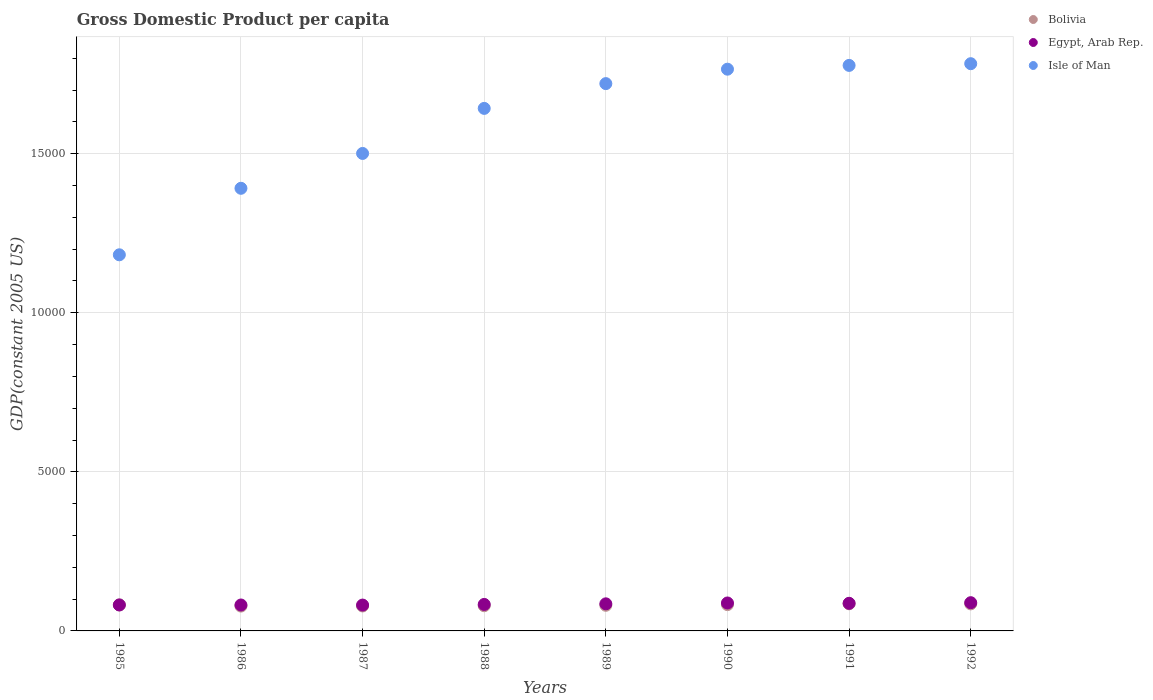Is the number of dotlines equal to the number of legend labels?
Your answer should be compact. Yes. What is the GDP per capita in Egypt, Arab Rep. in 1987?
Your answer should be compact. 812.49. Across all years, what is the maximum GDP per capita in Isle of Man?
Provide a short and direct response. 1.78e+04. Across all years, what is the minimum GDP per capita in Bolivia?
Offer a terse response. 780.57. In which year was the GDP per capita in Egypt, Arab Rep. minimum?
Offer a very short reply. 1987. What is the total GDP per capita in Bolivia in the graph?
Make the answer very short. 6507.87. What is the difference between the GDP per capita in Bolivia in 1987 and that in 1990?
Offer a very short reply. -42.18. What is the difference between the GDP per capita in Bolivia in 1992 and the GDP per capita in Egypt, Arab Rep. in 1986?
Offer a very short reply. 35.19. What is the average GDP per capita in Isle of Man per year?
Your response must be concise. 1.60e+04. In the year 1988, what is the difference between the GDP per capita in Bolivia and GDP per capita in Isle of Man?
Your answer should be compact. -1.56e+04. What is the ratio of the GDP per capita in Egypt, Arab Rep. in 1985 to that in 1987?
Provide a succinct answer. 1. Is the difference between the GDP per capita in Bolivia in 1986 and 1987 greater than the difference between the GDP per capita in Isle of Man in 1986 and 1987?
Your answer should be compact. Yes. What is the difference between the highest and the second highest GDP per capita in Bolivia?
Give a very brief answer. 2.88. What is the difference between the highest and the lowest GDP per capita in Bolivia?
Provide a succinct answer. 72.28. Is the sum of the GDP per capita in Bolivia in 1988 and 1989 greater than the maximum GDP per capita in Egypt, Arab Rep. across all years?
Make the answer very short. Yes. Is the GDP per capita in Bolivia strictly greater than the GDP per capita in Egypt, Arab Rep. over the years?
Offer a very short reply. No. How many dotlines are there?
Keep it short and to the point. 3. What is the difference between two consecutive major ticks on the Y-axis?
Offer a very short reply. 5000. Are the values on the major ticks of Y-axis written in scientific E-notation?
Provide a short and direct response. No. Where does the legend appear in the graph?
Provide a short and direct response. Top right. How many legend labels are there?
Your answer should be very brief. 3. What is the title of the graph?
Your answer should be compact. Gross Domestic Product per capita. Does "Faeroe Islands" appear as one of the legend labels in the graph?
Provide a succinct answer. No. What is the label or title of the Y-axis?
Your answer should be very brief. GDP(constant 2005 US). What is the GDP(constant 2005 US) of Bolivia in 1985?
Keep it short and to the point. 817.49. What is the GDP(constant 2005 US) in Egypt, Arab Rep. in 1985?
Give a very brief answer. 815.88. What is the GDP(constant 2005 US) in Isle of Man in 1985?
Offer a very short reply. 1.18e+04. What is the GDP(constant 2005 US) of Bolivia in 1986?
Make the answer very short. 780.57. What is the GDP(constant 2005 US) in Egypt, Arab Rep. in 1986?
Offer a very short reply. 814.79. What is the GDP(constant 2005 US) of Isle of Man in 1986?
Offer a very short reply. 1.39e+04. What is the GDP(constant 2005 US) in Bolivia in 1987?
Give a very brief answer. 784.11. What is the GDP(constant 2005 US) of Egypt, Arab Rep. in 1987?
Make the answer very short. 812.49. What is the GDP(constant 2005 US) of Isle of Man in 1987?
Provide a short and direct response. 1.50e+04. What is the GDP(constant 2005 US) of Bolivia in 1988?
Your answer should be compact. 791.25. What is the GDP(constant 2005 US) in Egypt, Arab Rep. in 1988?
Offer a terse response. 832.52. What is the GDP(constant 2005 US) of Isle of Man in 1988?
Provide a succinct answer. 1.64e+04. What is the GDP(constant 2005 US) in Bolivia in 1989?
Your answer should be very brief. 805.33. What is the GDP(constant 2005 US) in Egypt, Arab Rep. in 1989?
Provide a short and direct response. 851.4. What is the GDP(constant 2005 US) in Isle of Man in 1989?
Provide a succinct answer. 1.72e+04. What is the GDP(constant 2005 US) of Bolivia in 1990?
Keep it short and to the point. 826.29. What is the GDP(constant 2005 US) of Egypt, Arab Rep. in 1990?
Provide a short and direct response. 878.22. What is the GDP(constant 2005 US) of Isle of Man in 1990?
Give a very brief answer. 1.77e+04. What is the GDP(constant 2005 US) in Bolivia in 1991?
Provide a succinct answer. 852.86. What is the GDP(constant 2005 US) in Egypt, Arab Rep. in 1991?
Your response must be concise. 867.8. What is the GDP(constant 2005 US) in Isle of Man in 1991?
Give a very brief answer. 1.78e+04. What is the GDP(constant 2005 US) of Bolivia in 1992?
Keep it short and to the point. 849.98. What is the GDP(constant 2005 US) in Egypt, Arab Rep. in 1992?
Offer a very short reply. 887.31. What is the GDP(constant 2005 US) in Isle of Man in 1992?
Keep it short and to the point. 1.78e+04. Across all years, what is the maximum GDP(constant 2005 US) in Bolivia?
Your answer should be very brief. 852.86. Across all years, what is the maximum GDP(constant 2005 US) of Egypt, Arab Rep.?
Provide a succinct answer. 887.31. Across all years, what is the maximum GDP(constant 2005 US) in Isle of Man?
Your answer should be very brief. 1.78e+04. Across all years, what is the minimum GDP(constant 2005 US) in Bolivia?
Your response must be concise. 780.57. Across all years, what is the minimum GDP(constant 2005 US) of Egypt, Arab Rep.?
Keep it short and to the point. 812.49. Across all years, what is the minimum GDP(constant 2005 US) of Isle of Man?
Provide a short and direct response. 1.18e+04. What is the total GDP(constant 2005 US) in Bolivia in the graph?
Keep it short and to the point. 6507.87. What is the total GDP(constant 2005 US) of Egypt, Arab Rep. in the graph?
Keep it short and to the point. 6760.4. What is the total GDP(constant 2005 US) of Isle of Man in the graph?
Ensure brevity in your answer.  1.28e+05. What is the difference between the GDP(constant 2005 US) in Bolivia in 1985 and that in 1986?
Ensure brevity in your answer.  36.92. What is the difference between the GDP(constant 2005 US) in Egypt, Arab Rep. in 1985 and that in 1986?
Keep it short and to the point. 1.09. What is the difference between the GDP(constant 2005 US) of Isle of Man in 1985 and that in 1986?
Ensure brevity in your answer.  -2090.27. What is the difference between the GDP(constant 2005 US) in Bolivia in 1985 and that in 1987?
Offer a terse response. 33.38. What is the difference between the GDP(constant 2005 US) in Egypt, Arab Rep. in 1985 and that in 1987?
Provide a succinct answer. 3.38. What is the difference between the GDP(constant 2005 US) in Isle of Man in 1985 and that in 1987?
Your answer should be very brief. -3185.36. What is the difference between the GDP(constant 2005 US) of Bolivia in 1985 and that in 1988?
Your answer should be compact. 26.24. What is the difference between the GDP(constant 2005 US) in Egypt, Arab Rep. in 1985 and that in 1988?
Ensure brevity in your answer.  -16.64. What is the difference between the GDP(constant 2005 US) of Isle of Man in 1985 and that in 1988?
Your answer should be compact. -4601.39. What is the difference between the GDP(constant 2005 US) in Bolivia in 1985 and that in 1989?
Your answer should be compact. 12.16. What is the difference between the GDP(constant 2005 US) of Egypt, Arab Rep. in 1985 and that in 1989?
Ensure brevity in your answer.  -35.52. What is the difference between the GDP(constant 2005 US) in Isle of Man in 1985 and that in 1989?
Offer a very short reply. -5380.25. What is the difference between the GDP(constant 2005 US) of Bolivia in 1985 and that in 1990?
Offer a very short reply. -8.8. What is the difference between the GDP(constant 2005 US) of Egypt, Arab Rep. in 1985 and that in 1990?
Provide a short and direct response. -62.34. What is the difference between the GDP(constant 2005 US) in Isle of Man in 1985 and that in 1990?
Your response must be concise. -5833.59. What is the difference between the GDP(constant 2005 US) in Bolivia in 1985 and that in 1991?
Give a very brief answer. -35.36. What is the difference between the GDP(constant 2005 US) of Egypt, Arab Rep. in 1985 and that in 1991?
Keep it short and to the point. -51.93. What is the difference between the GDP(constant 2005 US) of Isle of Man in 1985 and that in 1991?
Ensure brevity in your answer.  -5952.38. What is the difference between the GDP(constant 2005 US) in Bolivia in 1985 and that in 1992?
Offer a terse response. -32.49. What is the difference between the GDP(constant 2005 US) of Egypt, Arab Rep. in 1985 and that in 1992?
Offer a terse response. -71.44. What is the difference between the GDP(constant 2005 US) in Isle of Man in 1985 and that in 1992?
Provide a succinct answer. -6006.14. What is the difference between the GDP(constant 2005 US) of Bolivia in 1986 and that in 1987?
Your answer should be very brief. -3.54. What is the difference between the GDP(constant 2005 US) in Egypt, Arab Rep. in 1986 and that in 1987?
Provide a short and direct response. 2.3. What is the difference between the GDP(constant 2005 US) in Isle of Man in 1986 and that in 1987?
Offer a terse response. -1095.08. What is the difference between the GDP(constant 2005 US) in Bolivia in 1986 and that in 1988?
Your response must be concise. -10.68. What is the difference between the GDP(constant 2005 US) of Egypt, Arab Rep. in 1986 and that in 1988?
Offer a terse response. -17.73. What is the difference between the GDP(constant 2005 US) in Isle of Man in 1986 and that in 1988?
Your response must be concise. -2511.12. What is the difference between the GDP(constant 2005 US) in Bolivia in 1986 and that in 1989?
Provide a succinct answer. -24.76. What is the difference between the GDP(constant 2005 US) in Egypt, Arab Rep. in 1986 and that in 1989?
Your answer should be very brief. -36.61. What is the difference between the GDP(constant 2005 US) in Isle of Man in 1986 and that in 1989?
Ensure brevity in your answer.  -3289.98. What is the difference between the GDP(constant 2005 US) in Bolivia in 1986 and that in 1990?
Ensure brevity in your answer.  -45.72. What is the difference between the GDP(constant 2005 US) in Egypt, Arab Rep. in 1986 and that in 1990?
Offer a terse response. -63.43. What is the difference between the GDP(constant 2005 US) in Isle of Man in 1986 and that in 1990?
Offer a terse response. -3743.32. What is the difference between the GDP(constant 2005 US) in Bolivia in 1986 and that in 1991?
Offer a terse response. -72.28. What is the difference between the GDP(constant 2005 US) in Egypt, Arab Rep. in 1986 and that in 1991?
Provide a succinct answer. -53.01. What is the difference between the GDP(constant 2005 US) in Isle of Man in 1986 and that in 1991?
Offer a very short reply. -3862.11. What is the difference between the GDP(constant 2005 US) in Bolivia in 1986 and that in 1992?
Ensure brevity in your answer.  -69.41. What is the difference between the GDP(constant 2005 US) in Egypt, Arab Rep. in 1986 and that in 1992?
Provide a short and direct response. -72.52. What is the difference between the GDP(constant 2005 US) of Isle of Man in 1986 and that in 1992?
Provide a succinct answer. -3915.87. What is the difference between the GDP(constant 2005 US) of Bolivia in 1987 and that in 1988?
Provide a short and direct response. -7.14. What is the difference between the GDP(constant 2005 US) in Egypt, Arab Rep. in 1987 and that in 1988?
Provide a succinct answer. -20.03. What is the difference between the GDP(constant 2005 US) in Isle of Man in 1987 and that in 1988?
Offer a terse response. -1416.04. What is the difference between the GDP(constant 2005 US) of Bolivia in 1987 and that in 1989?
Provide a short and direct response. -21.22. What is the difference between the GDP(constant 2005 US) of Egypt, Arab Rep. in 1987 and that in 1989?
Offer a terse response. -38.9. What is the difference between the GDP(constant 2005 US) of Isle of Man in 1987 and that in 1989?
Keep it short and to the point. -2194.89. What is the difference between the GDP(constant 2005 US) of Bolivia in 1987 and that in 1990?
Provide a short and direct response. -42.18. What is the difference between the GDP(constant 2005 US) of Egypt, Arab Rep. in 1987 and that in 1990?
Provide a short and direct response. -65.73. What is the difference between the GDP(constant 2005 US) of Isle of Man in 1987 and that in 1990?
Ensure brevity in your answer.  -2648.23. What is the difference between the GDP(constant 2005 US) of Bolivia in 1987 and that in 1991?
Ensure brevity in your answer.  -68.75. What is the difference between the GDP(constant 2005 US) in Egypt, Arab Rep. in 1987 and that in 1991?
Your answer should be very brief. -55.31. What is the difference between the GDP(constant 2005 US) of Isle of Man in 1987 and that in 1991?
Offer a terse response. -2767.03. What is the difference between the GDP(constant 2005 US) of Bolivia in 1987 and that in 1992?
Your response must be concise. -65.87. What is the difference between the GDP(constant 2005 US) in Egypt, Arab Rep. in 1987 and that in 1992?
Provide a short and direct response. -74.82. What is the difference between the GDP(constant 2005 US) in Isle of Man in 1987 and that in 1992?
Your answer should be very brief. -2820.79. What is the difference between the GDP(constant 2005 US) in Bolivia in 1988 and that in 1989?
Your response must be concise. -14.08. What is the difference between the GDP(constant 2005 US) in Egypt, Arab Rep. in 1988 and that in 1989?
Make the answer very short. -18.88. What is the difference between the GDP(constant 2005 US) of Isle of Man in 1988 and that in 1989?
Your response must be concise. -778.86. What is the difference between the GDP(constant 2005 US) in Bolivia in 1988 and that in 1990?
Make the answer very short. -35.04. What is the difference between the GDP(constant 2005 US) of Egypt, Arab Rep. in 1988 and that in 1990?
Keep it short and to the point. -45.7. What is the difference between the GDP(constant 2005 US) in Isle of Man in 1988 and that in 1990?
Your answer should be very brief. -1232.2. What is the difference between the GDP(constant 2005 US) in Bolivia in 1988 and that in 1991?
Your answer should be very brief. -61.61. What is the difference between the GDP(constant 2005 US) in Egypt, Arab Rep. in 1988 and that in 1991?
Give a very brief answer. -35.28. What is the difference between the GDP(constant 2005 US) in Isle of Man in 1988 and that in 1991?
Provide a short and direct response. -1350.99. What is the difference between the GDP(constant 2005 US) of Bolivia in 1988 and that in 1992?
Give a very brief answer. -58.73. What is the difference between the GDP(constant 2005 US) of Egypt, Arab Rep. in 1988 and that in 1992?
Your answer should be very brief. -54.79. What is the difference between the GDP(constant 2005 US) in Isle of Man in 1988 and that in 1992?
Your response must be concise. -1404.75. What is the difference between the GDP(constant 2005 US) in Bolivia in 1989 and that in 1990?
Give a very brief answer. -20.96. What is the difference between the GDP(constant 2005 US) of Egypt, Arab Rep. in 1989 and that in 1990?
Keep it short and to the point. -26.82. What is the difference between the GDP(constant 2005 US) of Isle of Man in 1989 and that in 1990?
Provide a short and direct response. -453.34. What is the difference between the GDP(constant 2005 US) in Bolivia in 1989 and that in 1991?
Offer a terse response. -47.53. What is the difference between the GDP(constant 2005 US) of Egypt, Arab Rep. in 1989 and that in 1991?
Give a very brief answer. -16.41. What is the difference between the GDP(constant 2005 US) of Isle of Man in 1989 and that in 1991?
Your answer should be very brief. -572.14. What is the difference between the GDP(constant 2005 US) in Bolivia in 1989 and that in 1992?
Provide a short and direct response. -44.65. What is the difference between the GDP(constant 2005 US) of Egypt, Arab Rep. in 1989 and that in 1992?
Provide a succinct answer. -35.92. What is the difference between the GDP(constant 2005 US) in Isle of Man in 1989 and that in 1992?
Offer a terse response. -625.9. What is the difference between the GDP(constant 2005 US) of Bolivia in 1990 and that in 1991?
Offer a terse response. -26.57. What is the difference between the GDP(constant 2005 US) of Egypt, Arab Rep. in 1990 and that in 1991?
Offer a terse response. 10.41. What is the difference between the GDP(constant 2005 US) of Isle of Man in 1990 and that in 1991?
Provide a short and direct response. -118.79. What is the difference between the GDP(constant 2005 US) in Bolivia in 1990 and that in 1992?
Offer a very short reply. -23.69. What is the difference between the GDP(constant 2005 US) in Egypt, Arab Rep. in 1990 and that in 1992?
Provide a short and direct response. -9.09. What is the difference between the GDP(constant 2005 US) of Isle of Man in 1990 and that in 1992?
Your answer should be compact. -172.55. What is the difference between the GDP(constant 2005 US) of Bolivia in 1991 and that in 1992?
Offer a very short reply. 2.88. What is the difference between the GDP(constant 2005 US) of Egypt, Arab Rep. in 1991 and that in 1992?
Ensure brevity in your answer.  -19.51. What is the difference between the GDP(constant 2005 US) of Isle of Man in 1991 and that in 1992?
Give a very brief answer. -53.76. What is the difference between the GDP(constant 2005 US) of Bolivia in 1985 and the GDP(constant 2005 US) of Egypt, Arab Rep. in 1986?
Provide a succinct answer. 2.7. What is the difference between the GDP(constant 2005 US) of Bolivia in 1985 and the GDP(constant 2005 US) of Isle of Man in 1986?
Your answer should be very brief. -1.31e+04. What is the difference between the GDP(constant 2005 US) of Egypt, Arab Rep. in 1985 and the GDP(constant 2005 US) of Isle of Man in 1986?
Provide a short and direct response. -1.31e+04. What is the difference between the GDP(constant 2005 US) of Bolivia in 1985 and the GDP(constant 2005 US) of Egypt, Arab Rep. in 1987?
Offer a terse response. 5. What is the difference between the GDP(constant 2005 US) in Bolivia in 1985 and the GDP(constant 2005 US) in Isle of Man in 1987?
Your response must be concise. -1.42e+04. What is the difference between the GDP(constant 2005 US) of Egypt, Arab Rep. in 1985 and the GDP(constant 2005 US) of Isle of Man in 1987?
Your response must be concise. -1.42e+04. What is the difference between the GDP(constant 2005 US) in Bolivia in 1985 and the GDP(constant 2005 US) in Egypt, Arab Rep. in 1988?
Offer a very short reply. -15.03. What is the difference between the GDP(constant 2005 US) of Bolivia in 1985 and the GDP(constant 2005 US) of Isle of Man in 1988?
Provide a succinct answer. -1.56e+04. What is the difference between the GDP(constant 2005 US) in Egypt, Arab Rep. in 1985 and the GDP(constant 2005 US) in Isle of Man in 1988?
Provide a short and direct response. -1.56e+04. What is the difference between the GDP(constant 2005 US) of Bolivia in 1985 and the GDP(constant 2005 US) of Egypt, Arab Rep. in 1989?
Offer a very short reply. -33.9. What is the difference between the GDP(constant 2005 US) of Bolivia in 1985 and the GDP(constant 2005 US) of Isle of Man in 1989?
Give a very brief answer. -1.64e+04. What is the difference between the GDP(constant 2005 US) in Egypt, Arab Rep. in 1985 and the GDP(constant 2005 US) in Isle of Man in 1989?
Provide a short and direct response. -1.64e+04. What is the difference between the GDP(constant 2005 US) of Bolivia in 1985 and the GDP(constant 2005 US) of Egypt, Arab Rep. in 1990?
Your answer should be very brief. -60.73. What is the difference between the GDP(constant 2005 US) of Bolivia in 1985 and the GDP(constant 2005 US) of Isle of Man in 1990?
Make the answer very short. -1.68e+04. What is the difference between the GDP(constant 2005 US) of Egypt, Arab Rep. in 1985 and the GDP(constant 2005 US) of Isle of Man in 1990?
Keep it short and to the point. -1.68e+04. What is the difference between the GDP(constant 2005 US) in Bolivia in 1985 and the GDP(constant 2005 US) in Egypt, Arab Rep. in 1991?
Give a very brief answer. -50.31. What is the difference between the GDP(constant 2005 US) of Bolivia in 1985 and the GDP(constant 2005 US) of Isle of Man in 1991?
Ensure brevity in your answer.  -1.70e+04. What is the difference between the GDP(constant 2005 US) of Egypt, Arab Rep. in 1985 and the GDP(constant 2005 US) of Isle of Man in 1991?
Offer a terse response. -1.70e+04. What is the difference between the GDP(constant 2005 US) of Bolivia in 1985 and the GDP(constant 2005 US) of Egypt, Arab Rep. in 1992?
Give a very brief answer. -69.82. What is the difference between the GDP(constant 2005 US) in Bolivia in 1985 and the GDP(constant 2005 US) in Isle of Man in 1992?
Your answer should be very brief. -1.70e+04. What is the difference between the GDP(constant 2005 US) of Egypt, Arab Rep. in 1985 and the GDP(constant 2005 US) of Isle of Man in 1992?
Make the answer very short. -1.70e+04. What is the difference between the GDP(constant 2005 US) of Bolivia in 1986 and the GDP(constant 2005 US) of Egypt, Arab Rep. in 1987?
Offer a terse response. -31.92. What is the difference between the GDP(constant 2005 US) in Bolivia in 1986 and the GDP(constant 2005 US) in Isle of Man in 1987?
Offer a terse response. -1.42e+04. What is the difference between the GDP(constant 2005 US) in Egypt, Arab Rep. in 1986 and the GDP(constant 2005 US) in Isle of Man in 1987?
Your answer should be very brief. -1.42e+04. What is the difference between the GDP(constant 2005 US) in Bolivia in 1986 and the GDP(constant 2005 US) in Egypt, Arab Rep. in 1988?
Your answer should be compact. -51.95. What is the difference between the GDP(constant 2005 US) of Bolivia in 1986 and the GDP(constant 2005 US) of Isle of Man in 1988?
Your answer should be very brief. -1.56e+04. What is the difference between the GDP(constant 2005 US) of Egypt, Arab Rep. in 1986 and the GDP(constant 2005 US) of Isle of Man in 1988?
Offer a terse response. -1.56e+04. What is the difference between the GDP(constant 2005 US) of Bolivia in 1986 and the GDP(constant 2005 US) of Egypt, Arab Rep. in 1989?
Provide a short and direct response. -70.82. What is the difference between the GDP(constant 2005 US) in Bolivia in 1986 and the GDP(constant 2005 US) in Isle of Man in 1989?
Make the answer very short. -1.64e+04. What is the difference between the GDP(constant 2005 US) of Egypt, Arab Rep. in 1986 and the GDP(constant 2005 US) of Isle of Man in 1989?
Offer a very short reply. -1.64e+04. What is the difference between the GDP(constant 2005 US) of Bolivia in 1986 and the GDP(constant 2005 US) of Egypt, Arab Rep. in 1990?
Your answer should be compact. -97.64. What is the difference between the GDP(constant 2005 US) in Bolivia in 1986 and the GDP(constant 2005 US) in Isle of Man in 1990?
Offer a very short reply. -1.69e+04. What is the difference between the GDP(constant 2005 US) in Egypt, Arab Rep. in 1986 and the GDP(constant 2005 US) in Isle of Man in 1990?
Offer a terse response. -1.68e+04. What is the difference between the GDP(constant 2005 US) in Bolivia in 1986 and the GDP(constant 2005 US) in Egypt, Arab Rep. in 1991?
Offer a terse response. -87.23. What is the difference between the GDP(constant 2005 US) of Bolivia in 1986 and the GDP(constant 2005 US) of Isle of Man in 1991?
Offer a very short reply. -1.70e+04. What is the difference between the GDP(constant 2005 US) of Egypt, Arab Rep. in 1986 and the GDP(constant 2005 US) of Isle of Man in 1991?
Ensure brevity in your answer.  -1.70e+04. What is the difference between the GDP(constant 2005 US) in Bolivia in 1986 and the GDP(constant 2005 US) in Egypt, Arab Rep. in 1992?
Make the answer very short. -106.74. What is the difference between the GDP(constant 2005 US) of Bolivia in 1986 and the GDP(constant 2005 US) of Isle of Man in 1992?
Keep it short and to the point. -1.70e+04. What is the difference between the GDP(constant 2005 US) in Egypt, Arab Rep. in 1986 and the GDP(constant 2005 US) in Isle of Man in 1992?
Provide a succinct answer. -1.70e+04. What is the difference between the GDP(constant 2005 US) of Bolivia in 1987 and the GDP(constant 2005 US) of Egypt, Arab Rep. in 1988?
Offer a terse response. -48.41. What is the difference between the GDP(constant 2005 US) in Bolivia in 1987 and the GDP(constant 2005 US) in Isle of Man in 1988?
Offer a terse response. -1.56e+04. What is the difference between the GDP(constant 2005 US) in Egypt, Arab Rep. in 1987 and the GDP(constant 2005 US) in Isle of Man in 1988?
Your response must be concise. -1.56e+04. What is the difference between the GDP(constant 2005 US) of Bolivia in 1987 and the GDP(constant 2005 US) of Egypt, Arab Rep. in 1989?
Give a very brief answer. -67.29. What is the difference between the GDP(constant 2005 US) of Bolivia in 1987 and the GDP(constant 2005 US) of Isle of Man in 1989?
Make the answer very short. -1.64e+04. What is the difference between the GDP(constant 2005 US) of Egypt, Arab Rep. in 1987 and the GDP(constant 2005 US) of Isle of Man in 1989?
Your answer should be very brief. -1.64e+04. What is the difference between the GDP(constant 2005 US) in Bolivia in 1987 and the GDP(constant 2005 US) in Egypt, Arab Rep. in 1990?
Your answer should be very brief. -94.11. What is the difference between the GDP(constant 2005 US) of Bolivia in 1987 and the GDP(constant 2005 US) of Isle of Man in 1990?
Offer a terse response. -1.69e+04. What is the difference between the GDP(constant 2005 US) in Egypt, Arab Rep. in 1987 and the GDP(constant 2005 US) in Isle of Man in 1990?
Make the answer very short. -1.68e+04. What is the difference between the GDP(constant 2005 US) of Bolivia in 1987 and the GDP(constant 2005 US) of Egypt, Arab Rep. in 1991?
Ensure brevity in your answer.  -83.69. What is the difference between the GDP(constant 2005 US) in Bolivia in 1987 and the GDP(constant 2005 US) in Isle of Man in 1991?
Provide a succinct answer. -1.70e+04. What is the difference between the GDP(constant 2005 US) in Egypt, Arab Rep. in 1987 and the GDP(constant 2005 US) in Isle of Man in 1991?
Give a very brief answer. -1.70e+04. What is the difference between the GDP(constant 2005 US) in Bolivia in 1987 and the GDP(constant 2005 US) in Egypt, Arab Rep. in 1992?
Offer a terse response. -103.2. What is the difference between the GDP(constant 2005 US) in Bolivia in 1987 and the GDP(constant 2005 US) in Isle of Man in 1992?
Keep it short and to the point. -1.70e+04. What is the difference between the GDP(constant 2005 US) in Egypt, Arab Rep. in 1987 and the GDP(constant 2005 US) in Isle of Man in 1992?
Offer a terse response. -1.70e+04. What is the difference between the GDP(constant 2005 US) in Bolivia in 1988 and the GDP(constant 2005 US) in Egypt, Arab Rep. in 1989?
Your answer should be compact. -60.15. What is the difference between the GDP(constant 2005 US) in Bolivia in 1988 and the GDP(constant 2005 US) in Isle of Man in 1989?
Your answer should be very brief. -1.64e+04. What is the difference between the GDP(constant 2005 US) of Egypt, Arab Rep. in 1988 and the GDP(constant 2005 US) of Isle of Man in 1989?
Offer a terse response. -1.64e+04. What is the difference between the GDP(constant 2005 US) in Bolivia in 1988 and the GDP(constant 2005 US) in Egypt, Arab Rep. in 1990?
Offer a terse response. -86.97. What is the difference between the GDP(constant 2005 US) in Bolivia in 1988 and the GDP(constant 2005 US) in Isle of Man in 1990?
Ensure brevity in your answer.  -1.69e+04. What is the difference between the GDP(constant 2005 US) in Egypt, Arab Rep. in 1988 and the GDP(constant 2005 US) in Isle of Man in 1990?
Your response must be concise. -1.68e+04. What is the difference between the GDP(constant 2005 US) of Bolivia in 1988 and the GDP(constant 2005 US) of Egypt, Arab Rep. in 1991?
Make the answer very short. -76.55. What is the difference between the GDP(constant 2005 US) in Bolivia in 1988 and the GDP(constant 2005 US) in Isle of Man in 1991?
Give a very brief answer. -1.70e+04. What is the difference between the GDP(constant 2005 US) in Egypt, Arab Rep. in 1988 and the GDP(constant 2005 US) in Isle of Man in 1991?
Your answer should be compact. -1.69e+04. What is the difference between the GDP(constant 2005 US) of Bolivia in 1988 and the GDP(constant 2005 US) of Egypt, Arab Rep. in 1992?
Keep it short and to the point. -96.06. What is the difference between the GDP(constant 2005 US) in Bolivia in 1988 and the GDP(constant 2005 US) in Isle of Man in 1992?
Ensure brevity in your answer.  -1.70e+04. What is the difference between the GDP(constant 2005 US) of Egypt, Arab Rep. in 1988 and the GDP(constant 2005 US) of Isle of Man in 1992?
Offer a very short reply. -1.70e+04. What is the difference between the GDP(constant 2005 US) in Bolivia in 1989 and the GDP(constant 2005 US) in Egypt, Arab Rep. in 1990?
Offer a terse response. -72.89. What is the difference between the GDP(constant 2005 US) in Bolivia in 1989 and the GDP(constant 2005 US) in Isle of Man in 1990?
Your answer should be compact. -1.68e+04. What is the difference between the GDP(constant 2005 US) in Egypt, Arab Rep. in 1989 and the GDP(constant 2005 US) in Isle of Man in 1990?
Offer a very short reply. -1.68e+04. What is the difference between the GDP(constant 2005 US) in Bolivia in 1989 and the GDP(constant 2005 US) in Egypt, Arab Rep. in 1991?
Give a very brief answer. -62.47. What is the difference between the GDP(constant 2005 US) of Bolivia in 1989 and the GDP(constant 2005 US) of Isle of Man in 1991?
Ensure brevity in your answer.  -1.70e+04. What is the difference between the GDP(constant 2005 US) of Egypt, Arab Rep. in 1989 and the GDP(constant 2005 US) of Isle of Man in 1991?
Your response must be concise. -1.69e+04. What is the difference between the GDP(constant 2005 US) of Bolivia in 1989 and the GDP(constant 2005 US) of Egypt, Arab Rep. in 1992?
Provide a succinct answer. -81.98. What is the difference between the GDP(constant 2005 US) in Bolivia in 1989 and the GDP(constant 2005 US) in Isle of Man in 1992?
Your response must be concise. -1.70e+04. What is the difference between the GDP(constant 2005 US) in Egypt, Arab Rep. in 1989 and the GDP(constant 2005 US) in Isle of Man in 1992?
Your response must be concise. -1.70e+04. What is the difference between the GDP(constant 2005 US) of Bolivia in 1990 and the GDP(constant 2005 US) of Egypt, Arab Rep. in 1991?
Your answer should be very brief. -41.51. What is the difference between the GDP(constant 2005 US) of Bolivia in 1990 and the GDP(constant 2005 US) of Isle of Man in 1991?
Provide a short and direct response. -1.69e+04. What is the difference between the GDP(constant 2005 US) of Egypt, Arab Rep. in 1990 and the GDP(constant 2005 US) of Isle of Man in 1991?
Make the answer very short. -1.69e+04. What is the difference between the GDP(constant 2005 US) in Bolivia in 1990 and the GDP(constant 2005 US) in Egypt, Arab Rep. in 1992?
Offer a very short reply. -61.02. What is the difference between the GDP(constant 2005 US) of Bolivia in 1990 and the GDP(constant 2005 US) of Isle of Man in 1992?
Your answer should be compact. -1.70e+04. What is the difference between the GDP(constant 2005 US) in Egypt, Arab Rep. in 1990 and the GDP(constant 2005 US) in Isle of Man in 1992?
Keep it short and to the point. -1.69e+04. What is the difference between the GDP(constant 2005 US) in Bolivia in 1991 and the GDP(constant 2005 US) in Egypt, Arab Rep. in 1992?
Offer a terse response. -34.46. What is the difference between the GDP(constant 2005 US) in Bolivia in 1991 and the GDP(constant 2005 US) in Isle of Man in 1992?
Make the answer very short. -1.70e+04. What is the difference between the GDP(constant 2005 US) in Egypt, Arab Rep. in 1991 and the GDP(constant 2005 US) in Isle of Man in 1992?
Provide a short and direct response. -1.70e+04. What is the average GDP(constant 2005 US) in Bolivia per year?
Give a very brief answer. 813.48. What is the average GDP(constant 2005 US) of Egypt, Arab Rep. per year?
Keep it short and to the point. 845.05. What is the average GDP(constant 2005 US) in Isle of Man per year?
Provide a short and direct response. 1.60e+04. In the year 1985, what is the difference between the GDP(constant 2005 US) of Bolivia and GDP(constant 2005 US) of Egypt, Arab Rep.?
Provide a short and direct response. 1.61. In the year 1985, what is the difference between the GDP(constant 2005 US) in Bolivia and GDP(constant 2005 US) in Isle of Man?
Keep it short and to the point. -1.10e+04. In the year 1985, what is the difference between the GDP(constant 2005 US) in Egypt, Arab Rep. and GDP(constant 2005 US) in Isle of Man?
Your answer should be compact. -1.10e+04. In the year 1986, what is the difference between the GDP(constant 2005 US) in Bolivia and GDP(constant 2005 US) in Egypt, Arab Rep.?
Offer a terse response. -34.22. In the year 1986, what is the difference between the GDP(constant 2005 US) in Bolivia and GDP(constant 2005 US) in Isle of Man?
Make the answer very short. -1.31e+04. In the year 1986, what is the difference between the GDP(constant 2005 US) of Egypt, Arab Rep. and GDP(constant 2005 US) of Isle of Man?
Your answer should be compact. -1.31e+04. In the year 1987, what is the difference between the GDP(constant 2005 US) in Bolivia and GDP(constant 2005 US) in Egypt, Arab Rep.?
Ensure brevity in your answer.  -28.38. In the year 1987, what is the difference between the GDP(constant 2005 US) in Bolivia and GDP(constant 2005 US) in Isle of Man?
Make the answer very short. -1.42e+04. In the year 1987, what is the difference between the GDP(constant 2005 US) in Egypt, Arab Rep. and GDP(constant 2005 US) in Isle of Man?
Provide a succinct answer. -1.42e+04. In the year 1988, what is the difference between the GDP(constant 2005 US) in Bolivia and GDP(constant 2005 US) in Egypt, Arab Rep.?
Provide a succinct answer. -41.27. In the year 1988, what is the difference between the GDP(constant 2005 US) in Bolivia and GDP(constant 2005 US) in Isle of Man?
Offer a terse response. -1.56e+04. In the year 1988, what is the difference between the GDP(constant 2005 US) in Egypt, Arab Rep. and GDP(constant 2005 US) in Isle of Man?
Your answer should be compact. -1.56e+04. In the year 1989, what is the difference between the GDP(constant 2005 US) in Bolivia and GDP(constant 2005 US) in Egypt, Arab Rep.?
Your answer should be very brief. -46.07. In the year 1989, what is the difference between the GDP(constant 2005 US) in Bolivia and GDP(constant 2005 US) in Isle of Man?
Provide a succinct answer. -1.64e+04. In the year 1989, what is the difference between the GDP(constant 2005 US) in Egypt, Arab Rep. and GDP(constant 2005 US) in Isle of Man?
Your answer should be compact. -1.63e+04. In the year 1990, what is the difference between the GDP(constant 2005 US) in Bolivia and GDP(constant 2005 US) in Egypt, Arab Rep.?
Offer a terse response. -51.93. In the year 1990, what is the difference between the GDP(constant 2005 US) of Bolivia and GDP(constant 2005 US) of Isle of Man?
Your response must be concise. -1.68e+04. In the year 1990, what is the difference between the GDP(constant 2005 US) in Egypt, Arab Rep. and GDP(constant 2005 US) in Isle of Man?
Your response must be concise. -1.68e+04. In the year 1991, what is the difference between the GDP(constant 2005 US) in Bolivia and GDP(constant 2005 US) in Egypt, Arab Rep.?
Keep it short and to the point. -14.95. In the year 1991, what is the difference between the GDP(constant 2005 US) in Bolivia and GDP(constant 2005 US) in Isle of Man?
Your response must be concise. -1.69e+04. In the year 1991, what is the difference between the GDP(constant 2005 US) in Egypt, Arab Rep. and GDP(constant 2005 US) in Isle of Man?
Make the answer very short. -1.69e+04. In the year 1992, what is the difference between the GDP(constant 2005 US) of Bolivia and GDP(constant 2005 US) of Egypt, Arab Rep.?
Provide a short and direct response. -37.33. In the year 1992, what is the difference between the GDP(constant 2005 US) in Bolivia and GDP(constant 2005 US) in Isle of Man?
Provide a short and direct response. -1.70e+04. In the year 1992, what is the difference between the GDP(constant 2005 US) of Egypt, Arab Rep. and GDP(constant 2005 US) of Isle of Man?
Your answer should be compact. -1.69e+04. What is the ratio of the GDP(constant 2005 US) in Bolivia in 1985 to that in 1986?
Provide a short and direct response. 1.05. What is the ratio of the GDP(constant 2005 US) in Egypt, Arab Rep. in 1985 to that in 1986?
Ensure brevity in your answer.  1. What is the ratio of the GDP(constant 2005 US) in Isle of Man in 1985 to that in 1986?
Provide a short and direct response. 0.85. What is the ratio of the GDP(constant 2005 US) of Bolivia in 1985 to that in 1987?
Provide a succinct answer. 1.04. What is the ratio of the GDP(constant 2005 US) of Isle of Man in 1985 to that in 1987?
Provide a succinct answer. 0.79. What is the ratio of the GDP(constant 2005 US) in Bolivia in 1985 to that in 1988?
Your response must be concise. 1.03. What is the ratio of the GDP(constant 2005 US) in Egypt, Arab Rep. in 1985 to that in 1988?
Your answer should be very brief. 0.98. What is the ratio of the GDP(constant 2005 US) of Isle of Man in 1985 to that in 1988?
Your answer should be compact. 0.72. What is the ratio of the GDP(constant 2005 US) in Bolivia in 1985 to that in 1989?
Make the answer very short. 1.02. What is the ratio of the GDP(constant 2005 US) of Isle of Man in 1985 to that in 1989?
Your answer should be compact. 0.69. What is the ratio of the GDP(constant 2005 US) in Bolivia in 1985 to that in 1990?
Your answer should be compact. 0.99. What is the ratio of the GDP(constant 2005 US) in Egypt, Arab Rep. in 1985 to that in 1990?
Your response must be concise. 0.93. What is the ratio of the GDP(constant 2005 US) of Isle of Man in 1985 to that in 1990?
Your answer should be very brief. 0.67. What is the ratio of the GDP(constant 2005 US) of Bolivia in 1985 to that in 1991?
Your answer should be very brief. 0.96. What is the ratio of the GDP(constant 2005 US) in Egypt, Arab Rep. in 1985 to that in 1991?
Provide a short and direct response. 0.94. What is the ratio of the GDP(constant 2005 US) in Isle of Man in 1985 to that in 1991?
Give a very brief answer. 0.67. What is the ratio of the GDP(constant 2005 US) of Bolivia in 1985 to that in 1992?
Your response must be concise. 0.96. What is the ratio of the GDP(constant 2005 US) of Egypt, Arab Rep. in 1985 to that in 1992?
Provide a succinct answer. 0.92. What is the ratio of the GDP(constant 2005 US) of Isle of Man in 1985 to that in 1992?
Provide a short and direct response. 0.66. What is the ratio of the GDP(constant 2005 US) in Bolivia in 1986 to that in 1987?
Provide a succinct answer. 1. What is the ratio of the GDP(constant 2005 US) in Egypt, Arab Rep. in 1986 to that in 1987?
Your answer should be compact. 1. What is the ratio of the GDP(constant 2005 US) of Isle of Man in 1986 to that in 1987?
Offer a terse response. 0.93. What is the ratio of the GDP(constant 2005 US) of Bolivia in 1986 to that in 1988?
Your answer should be very brief. 0.99. What is the ratio of the GDP(constant 2005 US) of Egypt, Arab Rep. in 1986 to that in 1988?
Your response must be concise. 0.98. What is the ratio of the GDP(constant 2005 US) of Isle of Man in 1986 to that in 1988?
Your response must be concise. 0.85. What is the ratio of the GDP(constant 2005 US) of Bolivia in 1986 to that in 1989?
Ensure brevity in your answer.  0.97. What is the ratio of the GDP(constant 2005 US) of Egypt, Arab Rep. in 1986 to that in 1989?
Provide a succinct answer. 0.96. What is the ratio of the GDP(constant 2005 US) of Isle of Man in 1986 to that in 1989?
Provide a short and direct response. 0.81. What is the ratio of the GDP(constant 2005 US) of Bolivia in 1986 to that in 1990?
Make the answer very short. 0.94. What is the ratio of the GDP(constant 2005 US) in Egypt, Arab Rep. in 1986 to that in 1990?
Give a very brief answer. 0.93. What is the ratio of the GDP(constant 2005 US) of Isle of Man in 1986 to that in 1990?
Provide a succinct answer. 0.79. What is the ratio of the GDP(constant 2005 US) in Bolivia in 1986 to that in 1991?
Ensure brevity in your answer.  0.92. What is the ratio of the GDP(constant 2005 US) of Egypt, Arab Rep. in 1986 to that in 1991?
Ensure brevity in your answer.  0.94. What is the ratio of the GDP(constant 2005 US) in Isle of Man in 1986 to that in 1991?
Ensure brevity in your answer.  0.78. What is the ratio of the GDP(constant 2005 US) in Bolivia in 1986 to that in 1992?
Provide a succinct answer. 0.92. What is the ratio of the GDP(constant 2005 US) in Egypt, Arab Rep. in 1986 to that in 1992?
Keep it short and to the point. 0.92. What is the ratio of the GDP(constant 2005 US) in Isle of Man in 1986 to that in 1992?
Give a very brief answer. 0.78. What is the ratio of the GDP(constant 2005 US) of Bolivia in 1987 to that in 1988?
Provide a short and direct response. 0.99. What is the ratio of the GDP(constant 2005 US) in Egypt, Arab Rep. in 1987 to that in 1988?
Provide a short and direct response. 0.98. What is the ratio of the GDP(constant 2005 US) of Isle of Man in 1987 to that in 1988?
Your response must be concise. 0.91. What is the ratio of the GDP(constant 2005 US) of Bolivia in 1987 to that in 1989?
Your response must be concise. 0.97. What is the ratio of the GDP(constant 2005 US) in Egypt, Arab Rep. in 1987 to that in 1989?
Offer a terse response. 0.95. What is the ratio of the GDP(constant 2005 US) of Isle of Man in 1987 to that in 1989?
Ensure brevity in your answer.  0.87. What is the ratio of the GDP(constant 2005 US) in Bolivia in 1987 to that in 1990?
Your answer should be compact. 0.95. What is the ratio of the GDP(constant 2005 US) in Egypt, Arab Rep. in 1987 to that in 1990?
Your response must be concise. 0.93. What is the ratio of the GDP(constant 2005 US) of Bolivia in 1987 to that in 1991?
Your answer should be very brief. 0.92. What is the ratio of the GDP(constant 2005 US) in Egypt, Arab Rep. in 1987 to that in 1991?
Keep it short and to the point. 0.94. What is the ratio of the GDP(constant 2005 US) of Isle of Man in 1987 to that in 1991?
Give a very brief answer. 0.84. What is the ratio of the GDP(constant 2005 US) in Bolivia in 1987 to that in 1992?
Ensure brevity in your answer.  0.92. What is the ratio of the GDP(constant 2005 US) in Egypt, Arab Rep. in 1987 to that in 1992?
Your answer should be very brief. 0.92. What is the ratio of the GDP(constant 2005 US) of Isle of Man in 1987 to that in 1992?
Make the answer very short. 0.84. What is the ratio of the GDP(constant 2005 US) of Bolivia in 1988 to that in 1989?
Offer a very short reply. 0.98. What is the ratio of the GDP(constant 2005 US) in Egypt, Arab Rep. in 1988 to that in 1989?
Your response must be concise. 0.98. What is the ratio of the GDP(constant 2005 US) of Isle of Man in 1988 to that in 1989?
Offer a very short reply. 0.95. What is the ratio of the GDP(constant 2005 US) in Bolivia in 1988 to that in 1990?
Make the answer very short. 0.96. What is the ratio of the GDP(constant 2005 US) in Egypt, Arab Rep. in 1988 to that in 1990?
Offer a very short reply. 0.95. What is the ratio of the GDP(constant 2005 US) in Isle of Man in 1988 to that in 1990?
Ensure brevity in your answer.  0.93. What is the ratio of the GDP(constant 2005 US) of Bolivia in 1988 to that in 1991?
Offer a very short reply. 0.93. What is the ratio of the GDP(constant 2005 US) of Egypt, Arab Rep. in 1988 to that in 1991?
Provide a short and direct response. 0.96. What is the ratio of the GDP(constant 2005 US) of Isle of Man in 1988 to that in 1991?
Offer a very short reply. 0.92. What is the ratio of the GDP(constant 2005 US) of Bolivia in 1988 to that in 1992?
Offer a terse response. 0.93. What is the ratio of the GDP(constant 2005 US) of Egypt, Arab Rep. in 1988 to that in 1992?
Your response must be concise. 0.94. What is the ratio of the GDP(constant 2005 US) of Isle of Man in 1988 to that in 1992?
Ensure brevity in your answer.  0.92. What is the ratio of the GDP(constant 2005 US) in Bolivia in 1989 to that in 1990?
Offer a very short reply. 0.97. What is the ratio of the GDP(constant 2005 US) of Egypt, Arab Rep. in 1989 to that in 1990?
Your response must be concise. 0.97. What is the ratio of the GDP(constant 2005 US) in Isle of Man in 1989 to that in 1990?
Give a very brief answer. 0.97. What is the ratio of the GDP(constant 2005 US) in Bolivia in 1989 to that in 1991?
Provide a short and direct response. 0.94. What is the ratio of the GDP(constant 2005 US) of Egypt, Arab Rep. in 1989 to that in 1991?
Your answer should be compact. 0.98. What is the ratio of the GDP(constant 2005 US) of Isle of Man in 1989 to that in 1991?
Your answer should be compact. 0.97. What is the ratio of the GDP(constant 2005 US) of Bolivia in 1989 to that in 1992?
Your answer should be compact. 0.95. What is the ratio of the GDP(constant 2005 US) of Egypt, Arab Rep. in 1989 to that in 1992?
Provide a succinct answer. 0.96. What is the ratio of the GDP(constant 2005 US) in Isle of Man in 1989 to that in 1992?
Your response must be concise. 0.96. What is the ratio of the GDP(constant 2005 US) of Bolivia in 1990 to that in 1991?
Give a very brief answer. 0.97. What is the ratio of the GDP(constant 2005 US) in Bolivia in 1990 to that in 1992?
Keep it short and to the point. 0.97. What is the ratio of the GDP(constant 2005 US) in Isle of Man in 1990 to that in 1992?
Ensure brevity in your answer.  0.99. What is the ratio of the GDP(constant 2005 US) in Bolivia in 1991 to that in 1992?
Your response must be concise. 1. What is the ratio of the GDP(constant 2005 US) in Isle of Man in 1991 to that in 1992?
Your answer should be very brief. 1. What is the difference between the highest and the second highest GDP(constant 2005 US) of Bolivia?
Ensure brevity in your answer.  2.88. What is the difference between the highest and the second highest GDP(constant 2005 US) in Egypt, Arab Rep.?
Keep it short and to the point. 9.09. What is the difference between the highest and the second highest GDP(constant 2005 US) of Isle of Man?
Keep it short and to the point. 53.76. What is the difference between the highest and the lowest GDP(constant 2005 US) of Bolivia?
Your answer should be very brief. 72.28. What is the difference between the highest and the lowest GDP(constant 2005 US) in Egypt, Arab Rep.?
Provide a succinct answer. 74.82. What is the difference between the highest and the lowest GDP(constant 2005 US) of Isle of Man?
Give a very brief answer. 6006.14. 